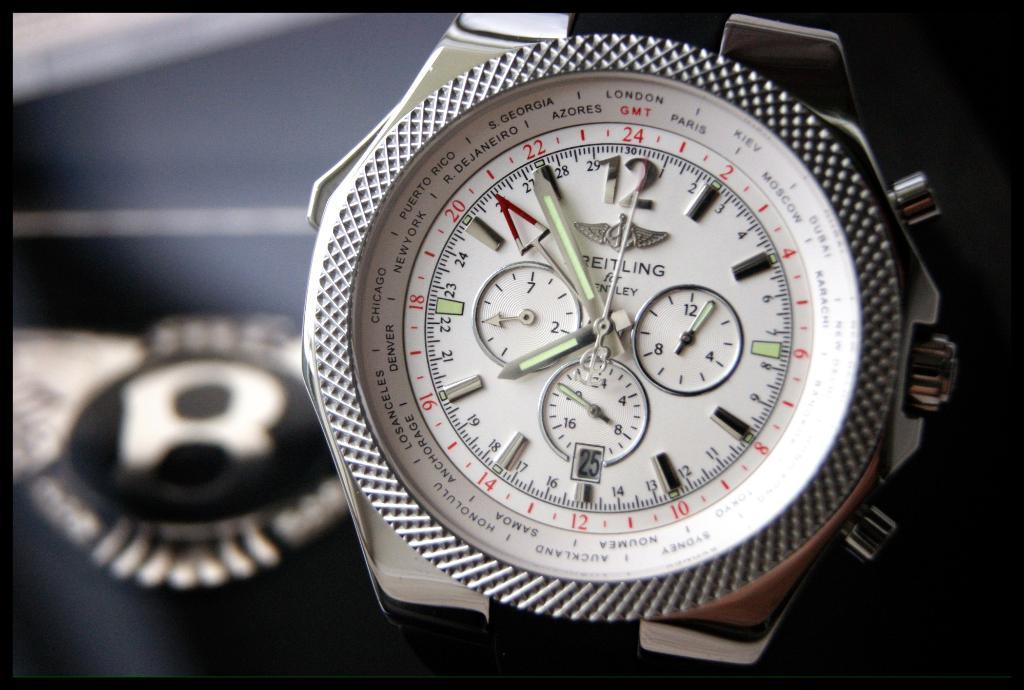<image>
Describe the image concisely. A Breitling watch shows the time as nearly five to eight. 